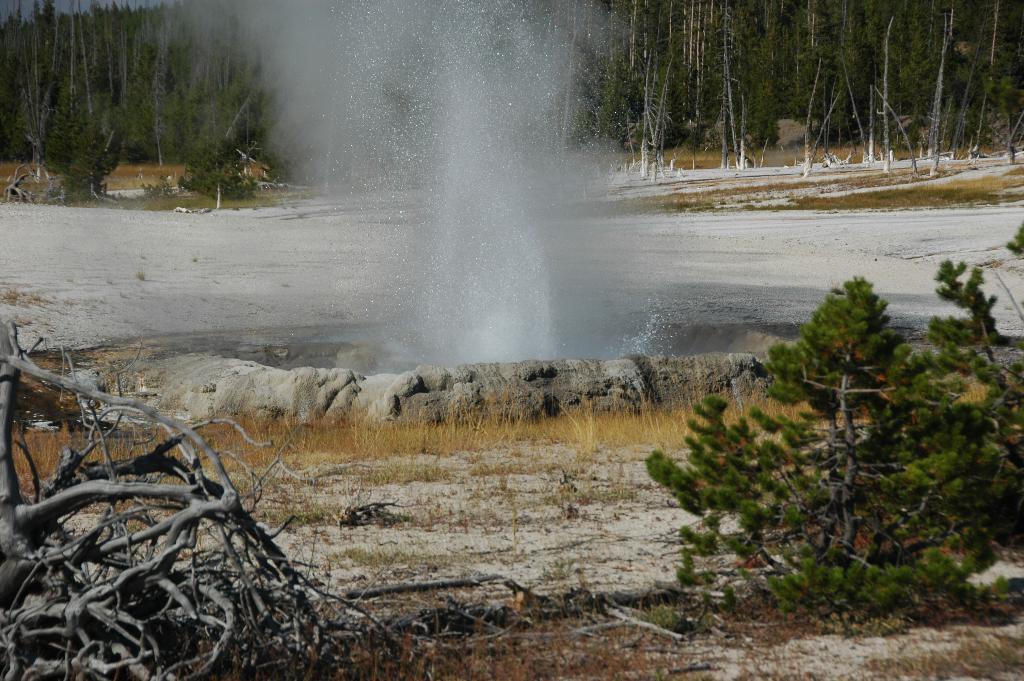How would you summarize this image in a sentence or two? In this picture I can see a hot spring, there is water, and in the background there are trees. 